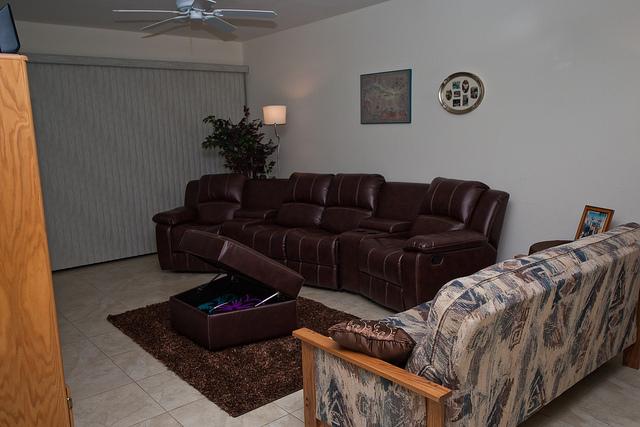Is the picture indoors or outdoors?
Be succinct. Indoors. Is the front light on?
Answer briefly. Yes. Is the couch made of leather?
Short answer required. Yes. How many rugs are shown?
Short answer required. 1. 